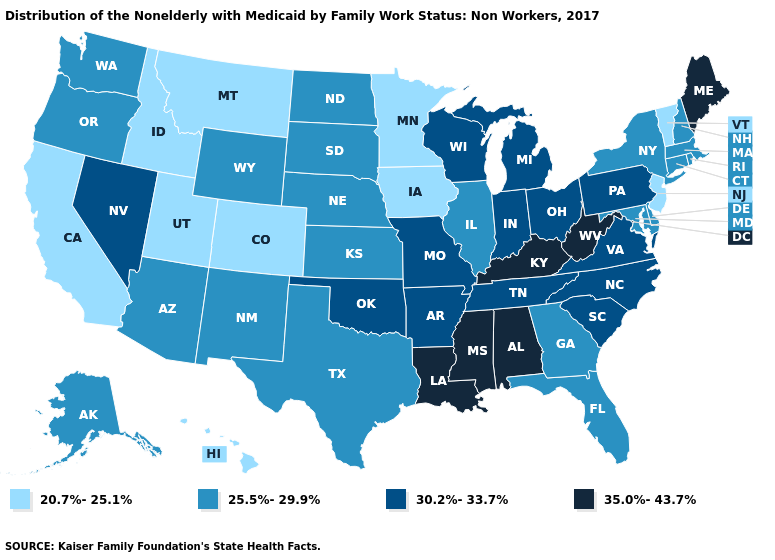Which states have the lowest value in the USA?
Concise answer only. California, Colorado, Hawaii, Idaho, Iowa, Minnesota, Montana, New Jersey, Utah, Vermont. What is the lowest value in the USA?
Be succinct. 20.7%-25.1%. What is the highest value in states that border Indiana?
Write a very short answer. 35.0%-43.7%. Name the states that have a value in the range 25.5%-29.9%?
Write a very short answer. Alaska, Arizona, Connecticut, Delaware, Florida, Georgia, Illinois, Kansas, Maryland, Massachusetts, Nebraska, New Hampshire, New Mexico, New York, North Dakota, Oregon, Rhode Island, South Dakota, Texas, Washington, Wyoming. Among the states that border Arkansas , which have the lowest value?
Short answer required. Texas. Name the states that have a value in the range 35.0%-43.7%?
Be succinct. Alabama, Kentucky, Louisiana, Maine, Mississippi, West Virginia. Does Washington have the same value as North Carolina?
Write a very short answer. No. How many symbols are there in the legend?
Concise answer only. 4. What is the value of Pennsylvania?
Answer briefly. 30.2%-33.7%. Name the states that have a value in the range 20.7%-25.1%?
Answer briefly. California, Colorado, Hawaii, Idaho, Iowa, Minnesota, Montana, New Jersey, Utah, Vermont. Name the states that have a value in the range 35.0%-43.7%?
Concise answer only. Alabama, Kentucky, Louisiana, Maine, Mississippi, West Virginia. Which states hav the highest value in the West?
Short answer required. Nevada. What is the highest value in the USA?
Quick response, please. 35.0%-43.7%. What is the value of Missouri?
Give a very brief answer. 30.2%-33.7%. Name the states that have a value in the range 30.2%-33.7%?
Give a very brief answer. Arkansas, Indiana, Michigan, Missouri, Nevada, North Carolina, Ohio, Oklahoma, Pennsylvania, South Carolina, Tennessee, Virginia, Wisconsin. 